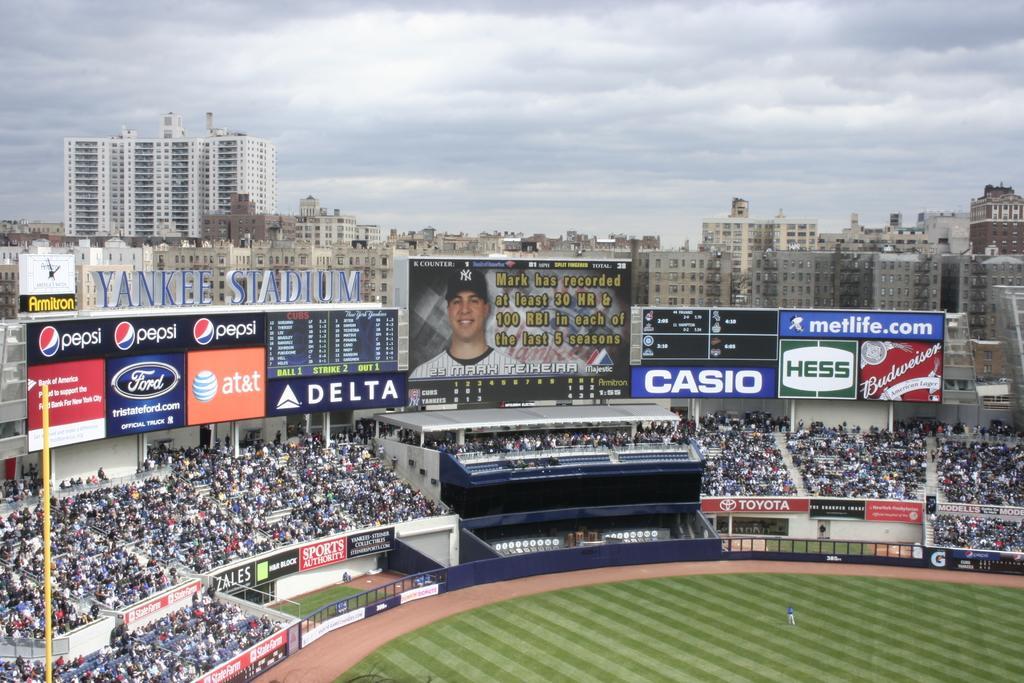In one or two sentences, can you explain what this image depicts? In this picture we can see there are groups of people, hoardings, boards, a name board and a screen in the stadium. Behind the hoardings, there are buildings and the sky. On the left side of the image, there is a pole. 